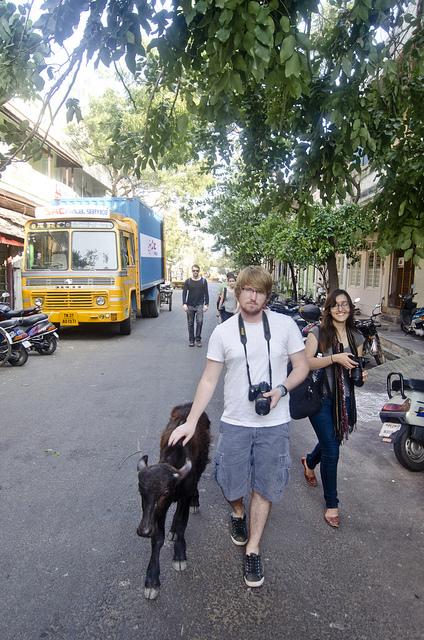Is the animal on a leash?
Concise answer only. No. Where is the man's camera?
Answer briefly. Around his neck. Are they in the city?
Write a very short answer. Yes. 